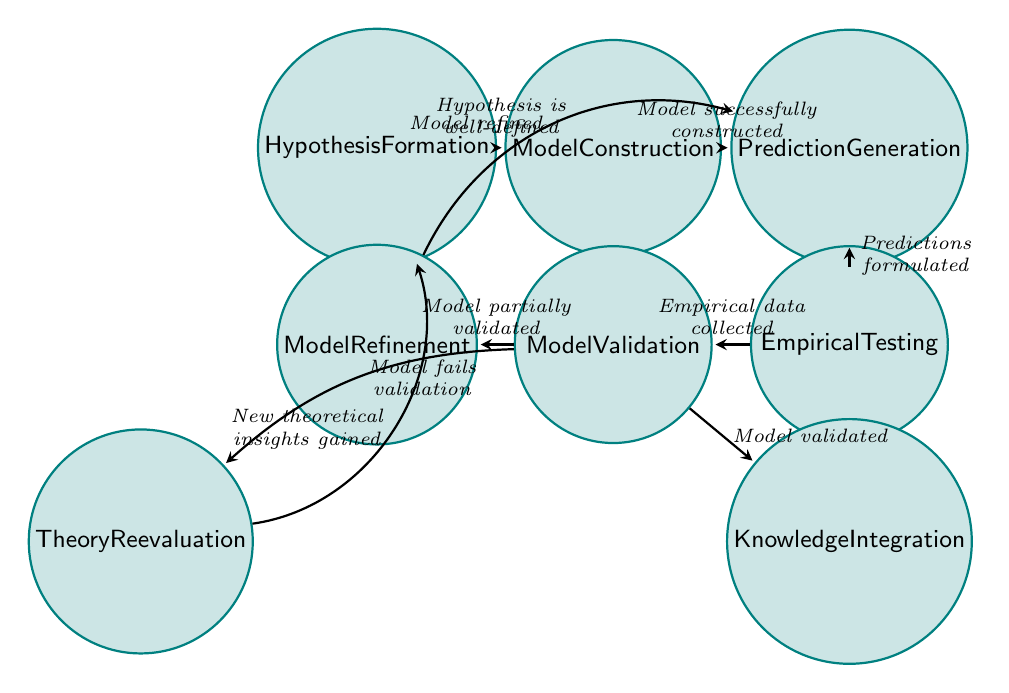What is the starting state in the diagram? The starting state, based on the flow of the diagram, is "Hypothesis Formation" as it is the first node with no incoming transitions.
Answer: Hypothesis Formation How many transitions are there in the diagram? Counting the arrows connecting different states, there are eight transitions present in the diagram.
Answer: Eight What is the condition required to transition from "Model Validation" to "Knowledge Integration"? The transition from "Model Validation" to "Knowledge Integration" requires that the "Model validated."
Answer: Model validated What occurs after "Empirical Testing" if the "Empirical data collected"? After "Empirical Testing," if empirical data has been collected, the next transition is to "Model Validation."
Answer: Model Validation Which state leads back to "Hypothesis Formation"? The state that leads back to "Hypothesis Formation" is "Theory Reevaluation," initiated by the condition of gaining new theoretical insights.
Answer: Theory Reevaluation What is the condition for "Model Refinement" to occur? "Model Refinement" occurs when the "Model partially validated," allowing for further enhancements to the model.
Answer: Model partially validated If a model fails validation, which state is entered? If a model fails validation, the state "Theory Reevaluation" is entered for a reassessment based on theoretical insights.
Answer: Theory Reevaluation What happens after "Model Refinement"? After "Model Refinement," if the model is refined, it goes back to "Prediction Generation" to formulate new predictions.
Answer: Prediction Generation 